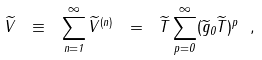Convert formula to latex. <formula><loc_0><loc_0><loc_500><loc_500>\widetilde { V } \ \equiv \ \sum _ { n = 1 } ^ { \infty } \widetilde { V } ^ { ( n ) } \ = \ \widetilde { T } \sum _ { p = 0 } ^ { \infty } ( \widetilde { g } _ { 0 } \widetilde { T } ) ^ { p } \ ,</formula> 